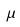<formula> <loc_0><loc_0><loc_500><loc_500>\mu</formula> 